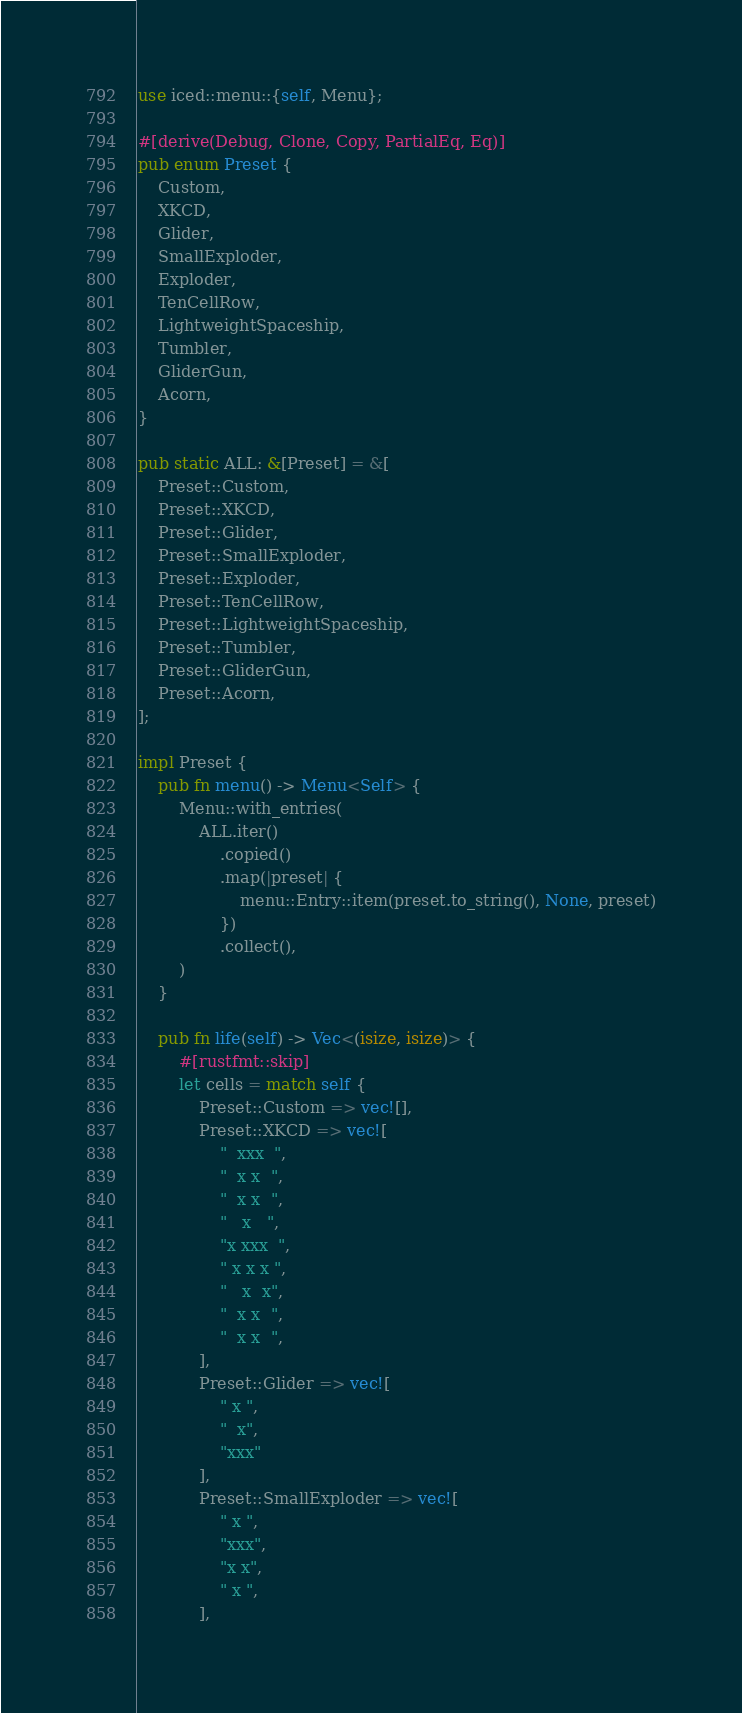<code> <loc_0><loc_0><loc_500><loc_500><_Rust_>use iced::menu::{self, Menu};

#[derive(Debug, Clone, Copy, PartialEq, Eq)]
pub enum Preset {
    Custom,
    XKCD,
    Glider,
    SmallExploder,
    Exploder,
    TenCellRow,
    LightweightSpaceship,
    Tumbler,
    GliderGun,
    Acorn,
}

pub static ALL: &[Preset] = &[
    Preset::Custom,
    Preset::XKCD,
    Preset::Glider,
    Preset::SmallExploder,
    Preset::Exploder,
    Preset::TenCellRow,
    Preset::LightweightSpaceship,
    Preset::Tumbler,
    Preset::GliderGun,
    Preset::Acorn,
];

impl Preset {
    pub fn menu() -> Menu<Self> {
        Menu::with_entries(
            ALL.iter()
                .copied()
                .map(|preset| {
                    menu::Entry::item(preset.to_string(), None, preset)
                })
                .collect(),
        )
    }

    pub fn life(self) -> Vec<(isize, isize)> {
        #[rustfmt::skip]
        let cells = match self {
            Preset::Custom => vec![],
            Preset::XKCD => vec![
                "  xxx  ",
                "  x x  ",
                "  x x  ",
                "   x   ",
                "x xxx  ",
                " x x x ",
                "   x  x",
                "  x x  ",
                "  x x  ",
            ],
            Preset::Glider => vec![
                " x ",
                "  x",
                "xxx"
            ],
            Preset::SmallExploder => vec![
                " x ",
                "xxx",
                "x x",
                " x ",
            ],</code> 